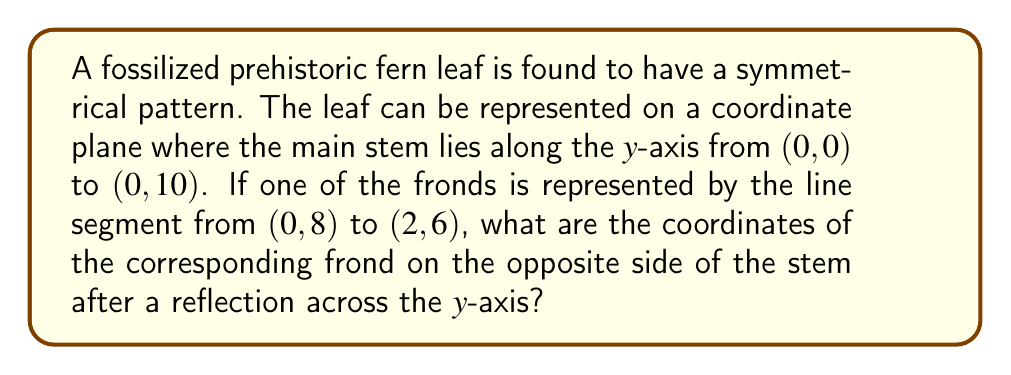Show me your answer to this math problem. Let's approach this step-by-step:

1) The original frond is represented by the line segment from (0, 8) to (2, 6).

2) We need to reflect this line segment across the y-axis.

3) In a reflection across the y-axis, the y-coordinates remain the same, while the x-coordinates change sign.

4) For the point (0, 8):
   - The x-coordinate is already 0, so it doesn't change.
   - The y-coordinate remains 8.
   So, this point stays at (0, 8).

5) For the point (2, 6):
   - The x-coordinate changes from 2 to -2.
   - The y-coordinate remains 6.
   So, this point becomes (-2, 6).

6) Therefore, the reflected frond is represented by the line segment from (0, 8) to (-2, 6).

This can be visualized as follows:

[asy]
import geometry;

size(200);
defaultpen(fontsize(10pt));

draw((-3,0)--(3,0),arrow=Arrow(TeXHead));
draw((0,-1)--(0,10),arrow=Arrow(TeXHead));

draw((0,0)--(0,10),linewidth(1.5));
draw((0,8)--(2,6),linewidth(1));
draw((0,8)--(-2,6),linewidth(1),dashed);

label("x", (3,0), E);
label("y", (0,10), N);
label("(0,8)", (0,8), NE);
label("(2,6)", (2,6), E);
label("(-2,6)", (-2,6), W);

dot((0,8));
dot((2,6));
dot((-2,6));
[/asy]
Answer: $(-2, 6)$ 